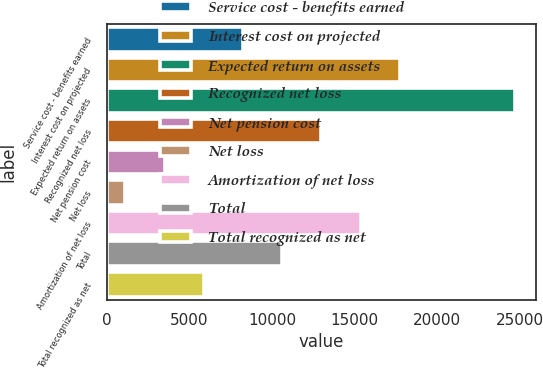<chart> <loc_0><loc_0><loc_500><loc_500><bar_chart><fcel>Service cost - benefits earned<fcel>Interest cost on projected<fcel>Expected return on assets<fcel>Recognized net loss<fcel>Net pension cost<fcel>Net loss<fcel>Amortization of net loss<fcel>Total<fcel>Total recognized as net<nl><fcel>8265.6<fcel>17710.8<fcel>24722<fcel>12988.2<fcel>3543<fcel>1109<fcel>15349.5<fcel>10626.9<fcel>5904.3<nl></chart> 